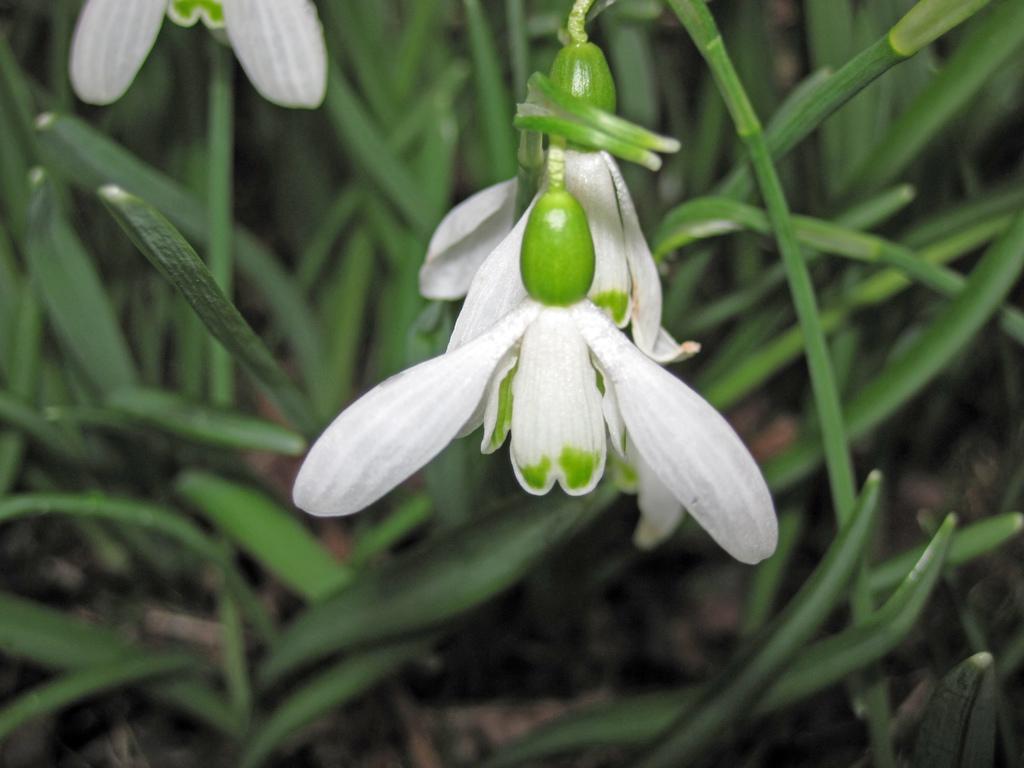Can you describe this image briefly? In the picture we can see some plants and to it we can see some flowers which are white in color. 